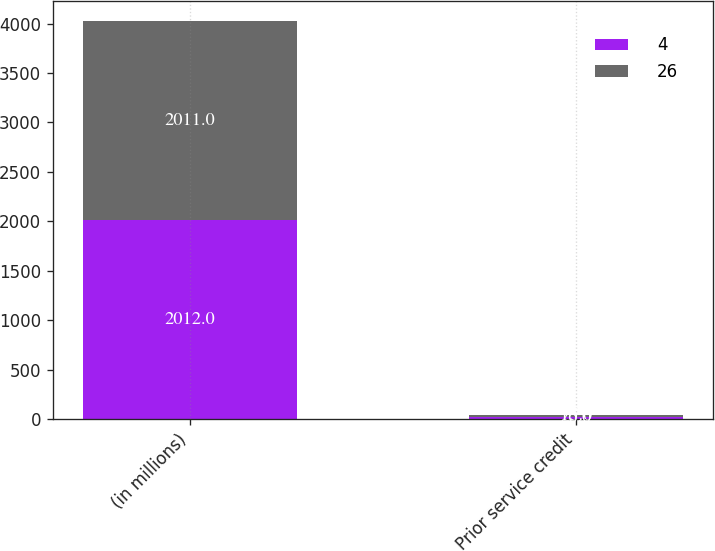<chart> <loc_0><loc_0><loc_500><loc_500><stacked_bar_chart><ecel><fcel>(in millions)<fcel>Prior service credit<nl><fcel>4<fcel>2012<fcel>26<nl><fcel>26<fcel>2011<fcel>15<nl></chart> 